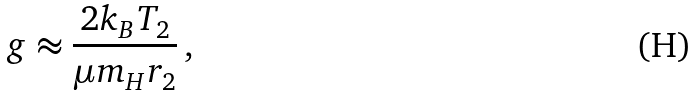<formula> <loc_0><loc_0><loc_500><loc_500>g \approx \frac { 2 k _ { B } T _ { 2 } } { \mu m _ { H } r _ { 2 } } \, ,</formula> 